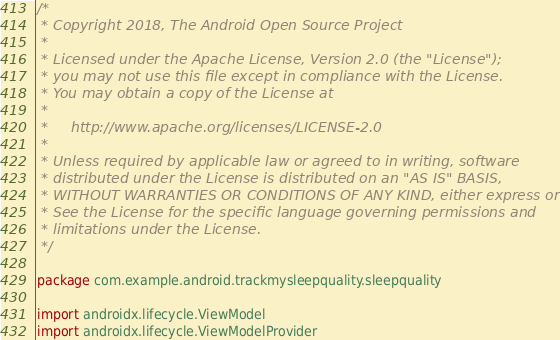Convert code to text. <code><loc_0><loc_0><loc_500><loc_500><_Kotlin_>/*
 * Copyright 2018, The Android Open Source Project
 *
 * Licensed under the Apache License, Version 2.0 (the "License");
 * you may not use this file except in compliance with the License.
 * You may obtain a copy of the License at
 *
 *     http://www.apache.org/licenses/LICENSE-2.0
 *
 * Unless required by applicable law or agreed to in writing, software
 * distributed under the License is distributed on an "AS IS" BASIS,
 * WITHOUT WARRANTIES OR CONDITIONS OF ANY KIND, either express or implied.
 * See the License for the specific language governing permissions and
 * limitations under the License.
 */

package com.example.android.trackmysleepquality.sleepquality

import androidx.lifecycle.ViewModel
import androidx.lifecycle.ViewModelProvider</code> 